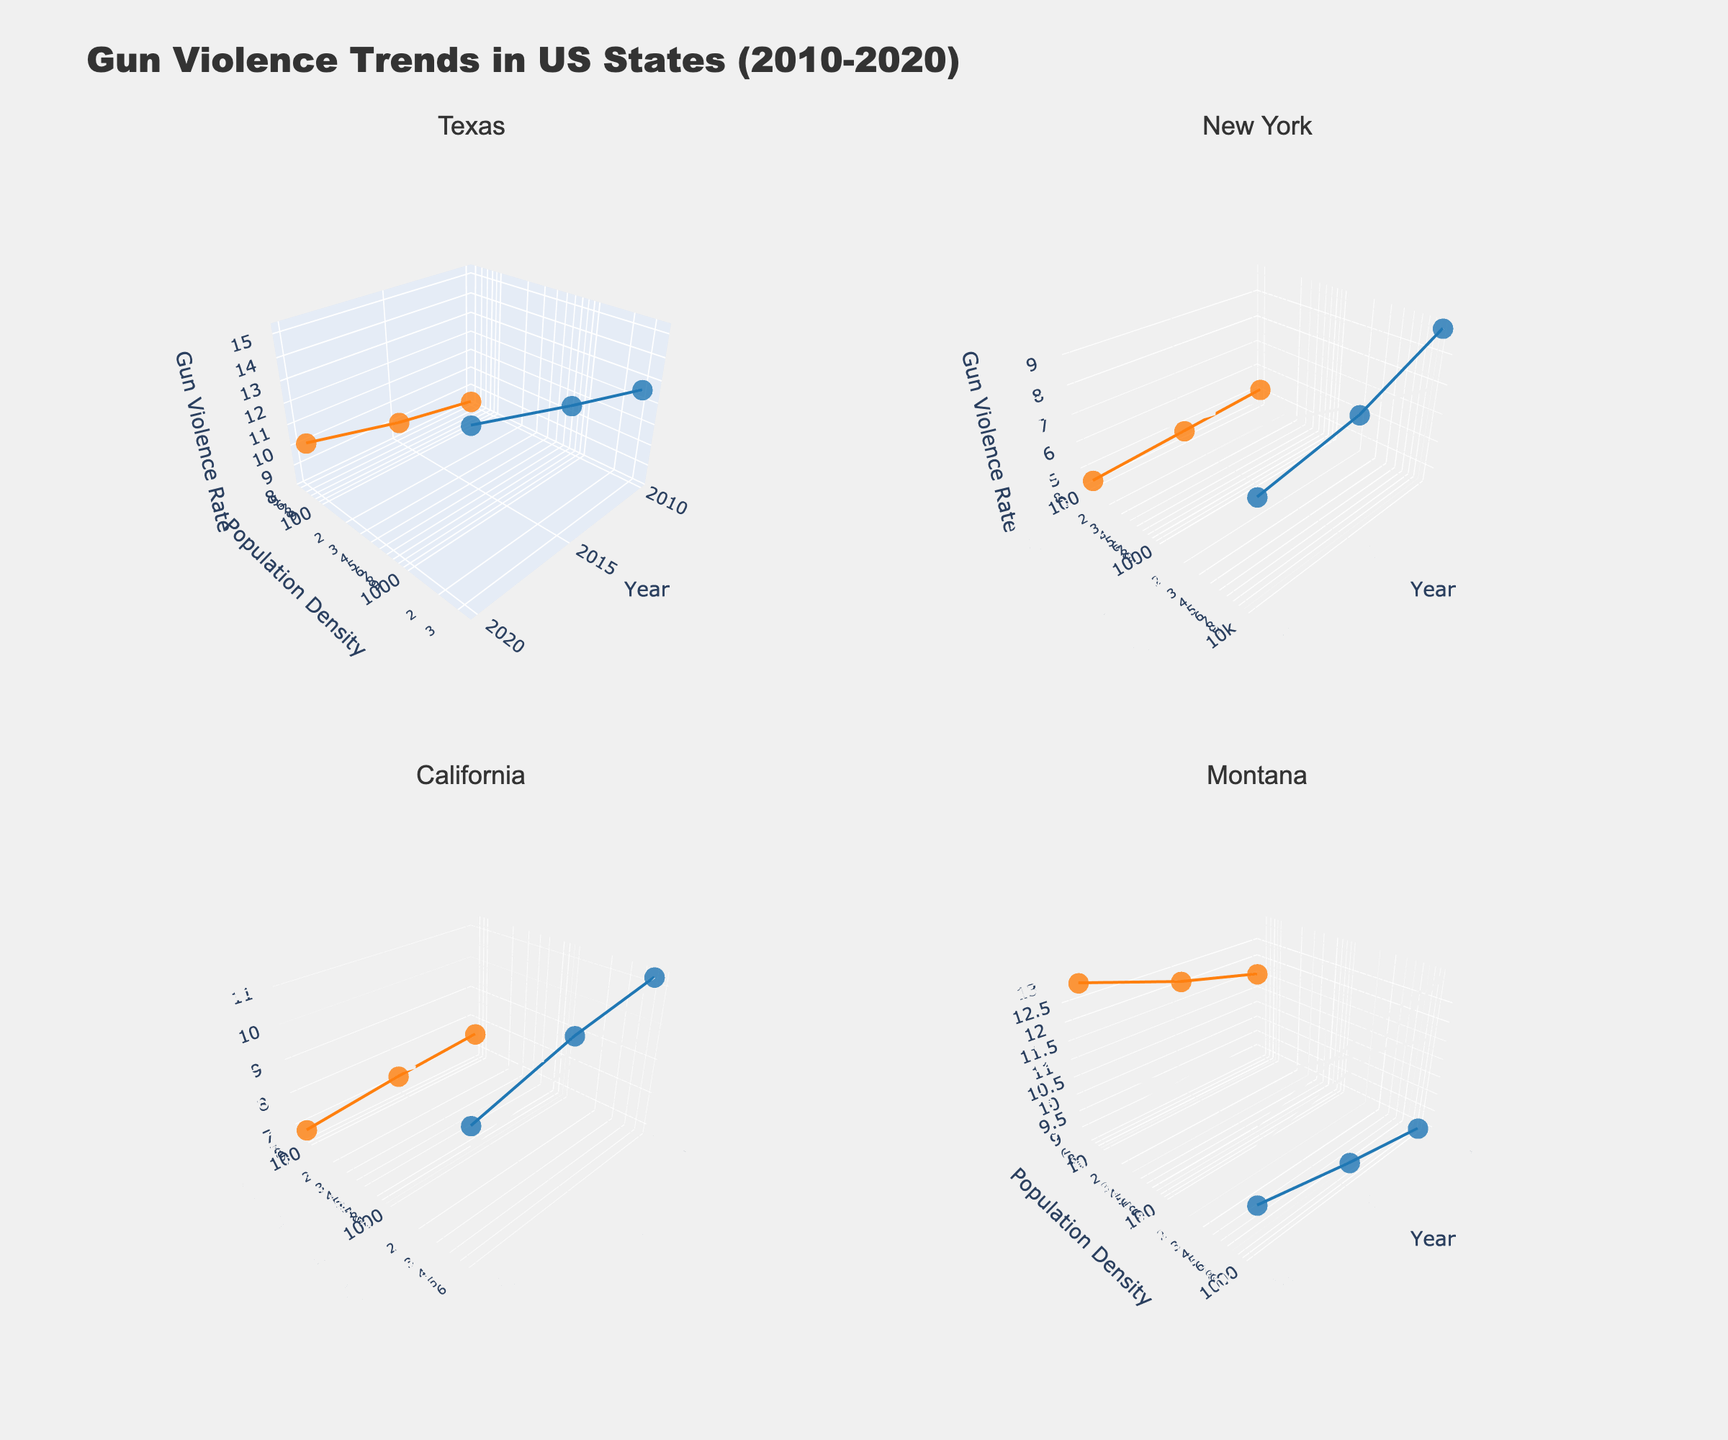What is the overall trend in gun violence rates in urban areas in Texas between 2010 and 2020? The urban gun violence rate in Texas shows an increasing trend from 12.5 in 2010 to 15.2 in 2020. This can be observed from the rising direction of the line connecting the markers for urban Texas data points.
Answer: Increasing What is the population density of rural areas in Montana in 2015? The figure shows three markers for rural Montana data points, with the middle marker representing the year 2015. The population density at this marker is approximately 6.
Answer: 6 How do the gun violence rates in urban and rural areas of New York compare in 2020? The endpoint markers for New York's urban and rural areas in 2020 show that urban areas have a gun violence rate of 7.9, while rural areas have a rate of 4.5.
Answer: Urban areas higher Which state has the highest gun violence rate in rural areas in 2020, and what is the value? Observing the markers at the end of each state subplot for rural areas in 2020, Montana has the highest gun violence rate at 13.1.
Answer: Montana, 13.1 What is the difference in gun ownership rates between urban and rural areas in California in 2010? From the figure, 2010 markers for urban and rural California show a gun ownership rate of 30% and 50%, respectively. The difference is 50 - 30 = 20%.
Answer: 20% Which state has the highest population density in urban areas throughout the study period? New York has the highest population density in urban areas, consistently above 10,000 across all years, as evident from the vertical axis of the markers in the New York subplot.
Answer: New York What is the trend in gun violence rates in rural areas of Montana between 2010 and 2020? The markers for rural Montana data points show an increasing trend from 11.5 in 2010 to 13.1 in 2020.
Answer: Increasing How does the population density of urban Texas compare to urban New York in 2015? By comparing the markers for urban areas of Texas and New York in 2015, Texas has a population density of 3200, while New York has 10,200. New York's density is substantially higher.
Answer: New York higher 